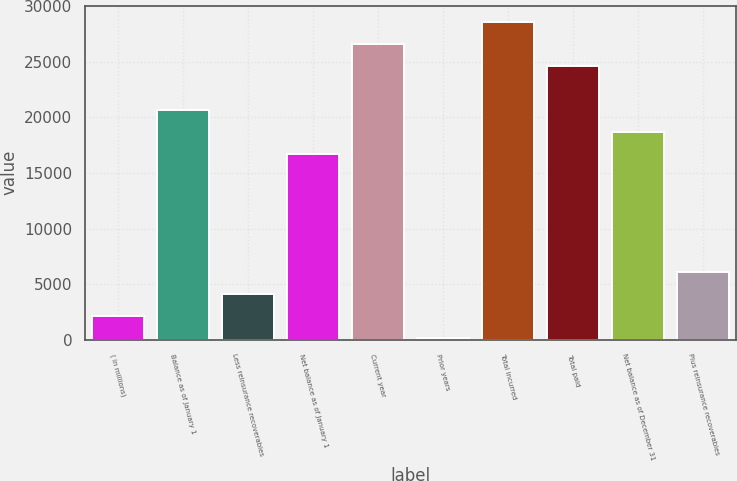<chart> <loc_0><loc_0><loc_500><loc_500><bar_chart><fcel>( in millions)<fcel>Balance as of January 1<fcel>Less reinsurance recoverables<fcel>Net balance as of January 1<fcel>Current year<fcel>Prior years<fcel>Total incurred<fcel>Total paid<fcel>Net balance as of December 31<fcel>Plus reinsurance recoverables<nl><fcel>2159.4<fcel>20638.8<fcel>4148.8<fcel>16660<fcel>26607<fcel>170<fcel>28596.4<fcel>24617.6<fcel>18649.4<fcel>6138.2<nl></chart> 